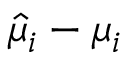Convert formula to latex. <formula><loc_0><loc_0><loc_500><loc_500>\hat { \mu } _ { i } - \mu _ { i }</formula> 